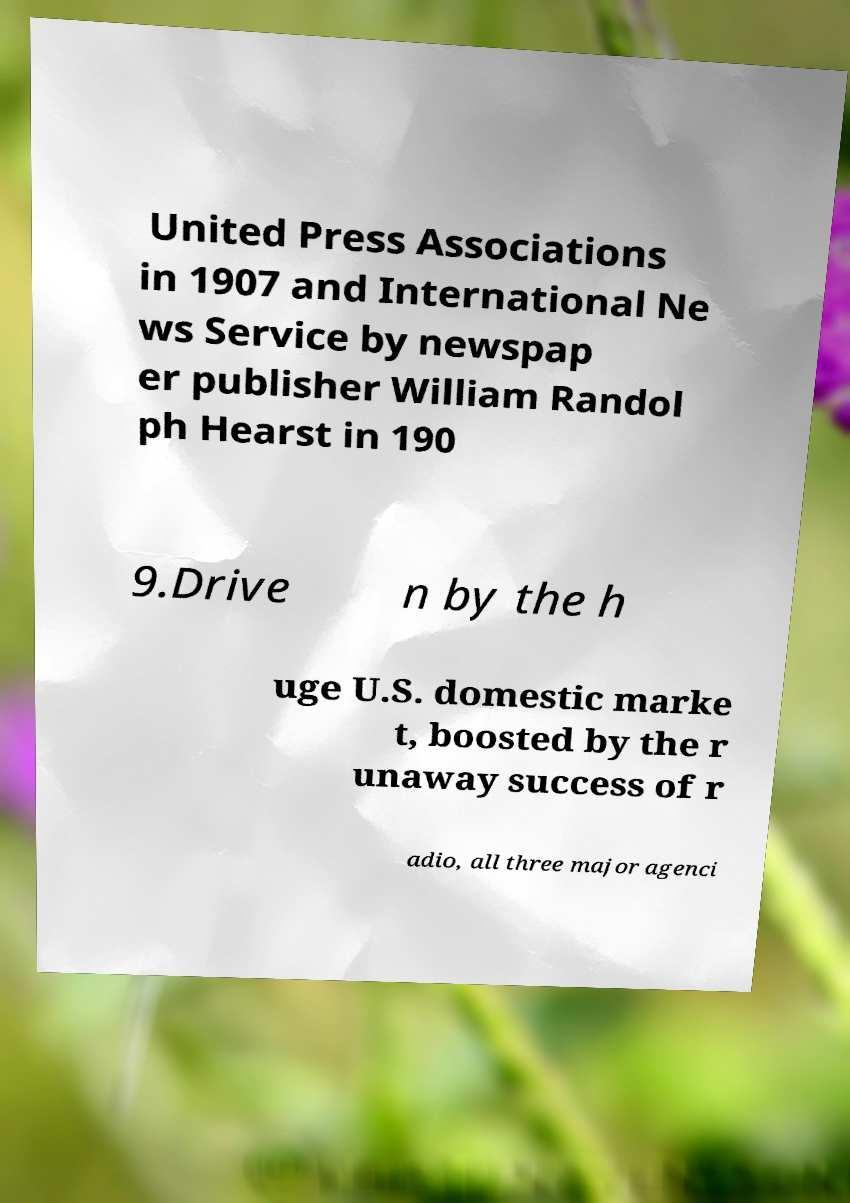I need the written content from this picture converted into text. Can you do that? United Press Associations in 1907 and International Ne ws Service by newspap er publisher William Randol ph Hearst in 190 9.Drive n by the h uge U.S. domestic marke t, boosted by the r unaway success of r adio, all three major agenci 